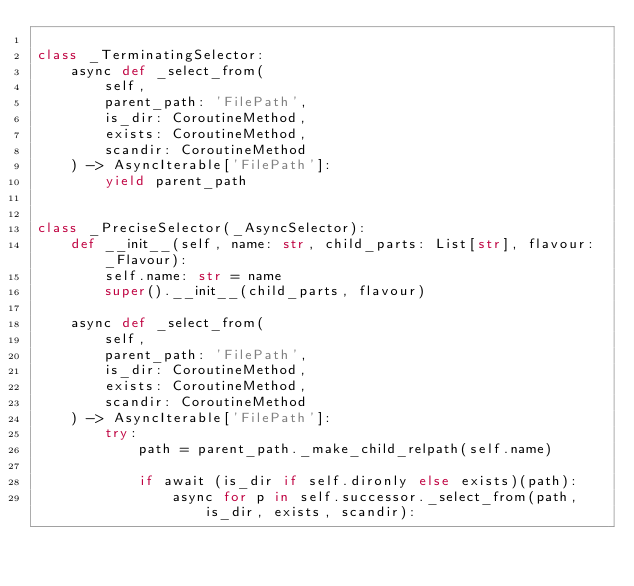<code> <loc_0><loc_0><loc_500><loc_500><_Python_>
class _TerminatingSelector:
    async def _select_from(
        self,
        parent_path: 'FilePath', 
        is_dir: CoroutineMethod, 
        exists: CoroutineMethod, 
        scandir: CoroutineMethod
    ) -> AsyncIterable['FilePath']:
        yield parent_path


class _PreciseSelector(_AsyncSelector):
    def __init__(self, name: str, child_parts: List[str], flavour: _Flavour):
        self.name: str = name
        super().__init__(child_parts, flavour)

    async def _select_from(
        self,
        parent_path: 'FilePath', 
        is_dir: CoroutineMethod, 
        exists: CoroutineMethod, 
        scandir: CoroutineMethod
    ) -> AsyncIterable['FilePath']:
        try:
            path = parent_path._make_child_relpath(self.name)

            if await (is_dir if self.dironly else exists)(path):
                async for p in self.successor._select_from(path, is_dir, exists, scandir):</code> 